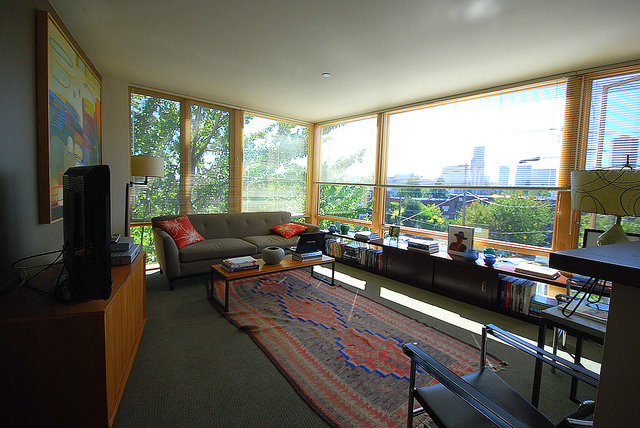<image>How long is the rug? The length of the rug is unknown. It could be anywhere from 6 to 10 feet long. How long is the rug? It is unknown how long the rug is. It can be seen as very long or 6 ft, 8 ft or 10 ft. 